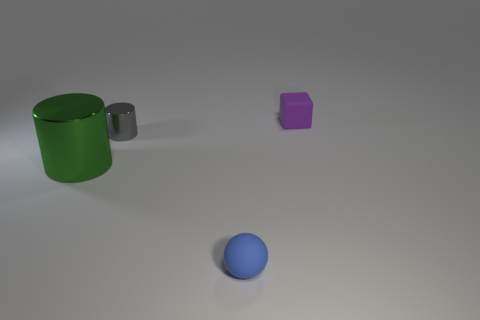Subtract all brown cylinders. Subtract all brown spheres. How many cylinders are left? 2 Add 3 matte things. How many objects exist? 7 Subtract all blocks. How many objects are left? 3 Add 3 blue balls. How many blue balls are left? 4 Add 4 cyan metallic spheres. How many cyan metallic spheres exist? 4 Subtract 1 blue spheres. How many objects are left? 3 Subtract all small blocks. Subtract all gray shiny cylinders. How many objects are left? 2 